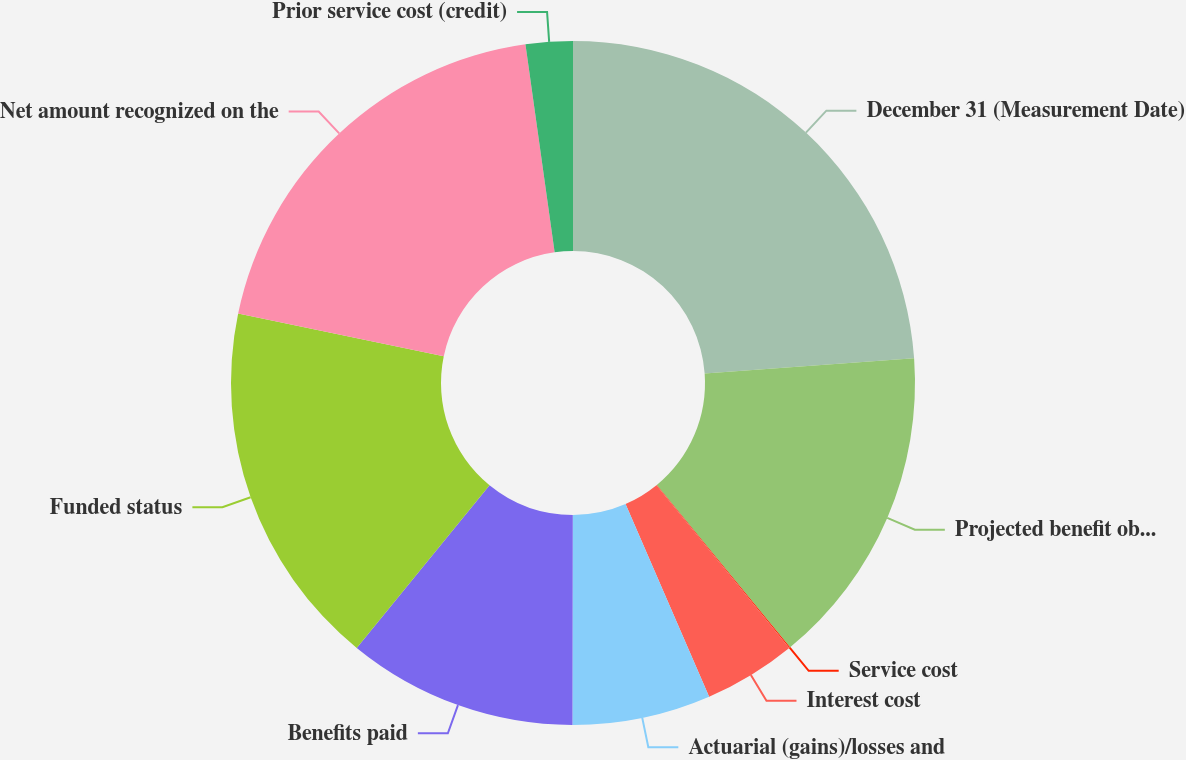Convert chart to OTSL. <chart><loc_0><loc_0><loc_500><loc_500><pie_chart><fcel>December 31 (Measurement Date)<fcel>Projected benefit obligation<fcel>Service cost<fcel>Interest cost<fcel>Actuarial (gains)/losses and<fcel>Benefits paid<fcel>Funded status<fcel>Net amount recognized on the<fcel>Prior service cost (credit)<nl><fcel>23.85%<fcel>15.2%<fcel>0.05%<fcel>4.38%<fcel>6.54%<fcel>10.87%<fcel>17.36%<fcel>19.52%<fcel>2.22%<nl></chart> 